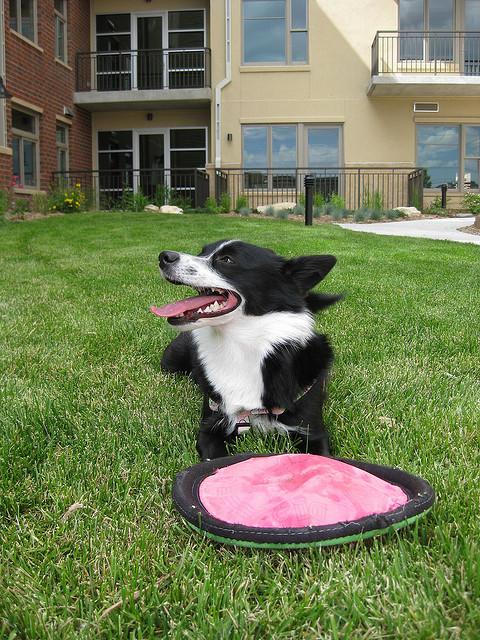What is on the ground behind the dog?
Answer briefly. Grass. How many dogs are in the picture?
Give a very brief answer. 1. Is the dog running?
Give a very brief answer. No. What is next to the dog on the ground?
Keep it brief. Frisbee. What kind of animal is shown?
Give a very brief answer. Dog. 